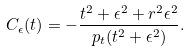<formula> <loc_0><loc_0><loc_500><loc_500>C _ { \epsilon } ( t ) = - \frac { t ^ { 2 } + \epsilon ^ { 2 } + r ^ { 2 } \epsilon ^ { 2 } } { p _ { t } ( t ^ { 2 } + \epsilon ^ { 2 } ) } .</formula> 